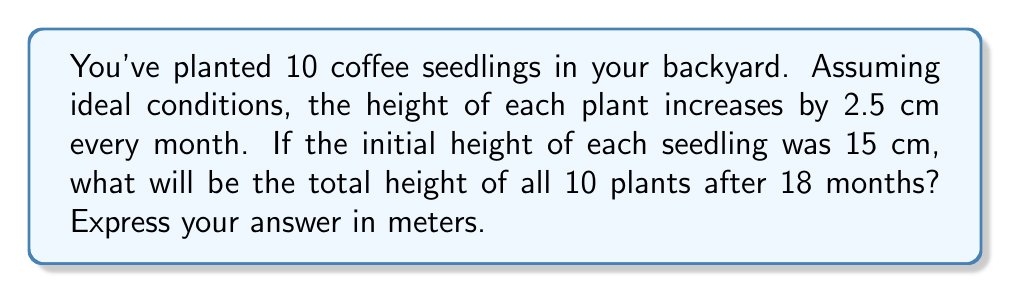Help me with this question. Let's approach this step-by-step using an arithmetic sequence:

1) First, let's identify the components of our arithmetic sequence:
   - Initial term (a₁) = 15 cm (initial height)
   - Common difference (d) = 2.5 cm (monthly growth)
   - Number of terms (n) = 18 + 1 = 19 (18 months of growth plus initial height)

2) The formula for the nth term of an arithmetic sequence is:
   $a_n = a_1 + (n-1)d$

3) Substituting our values:
   $a_{19} = 15 + (19-1)(2.5) = 15 + (18)(2.5) = 15 + 45 = 60$ cm

4) So, after 18 months, each plant will be 60 cm tall.

5) For all 10 plants, we multiply this height by 10:
   $60 \text{ cm} \times 10 = 600 \text{ cm}$

6) Convert to meters:
   $600 \text{ cm} = 6 \text{ m}$

Therefore, the total height of all 10 plants after 18 months will be 6 meters.
Answer: 6 m 